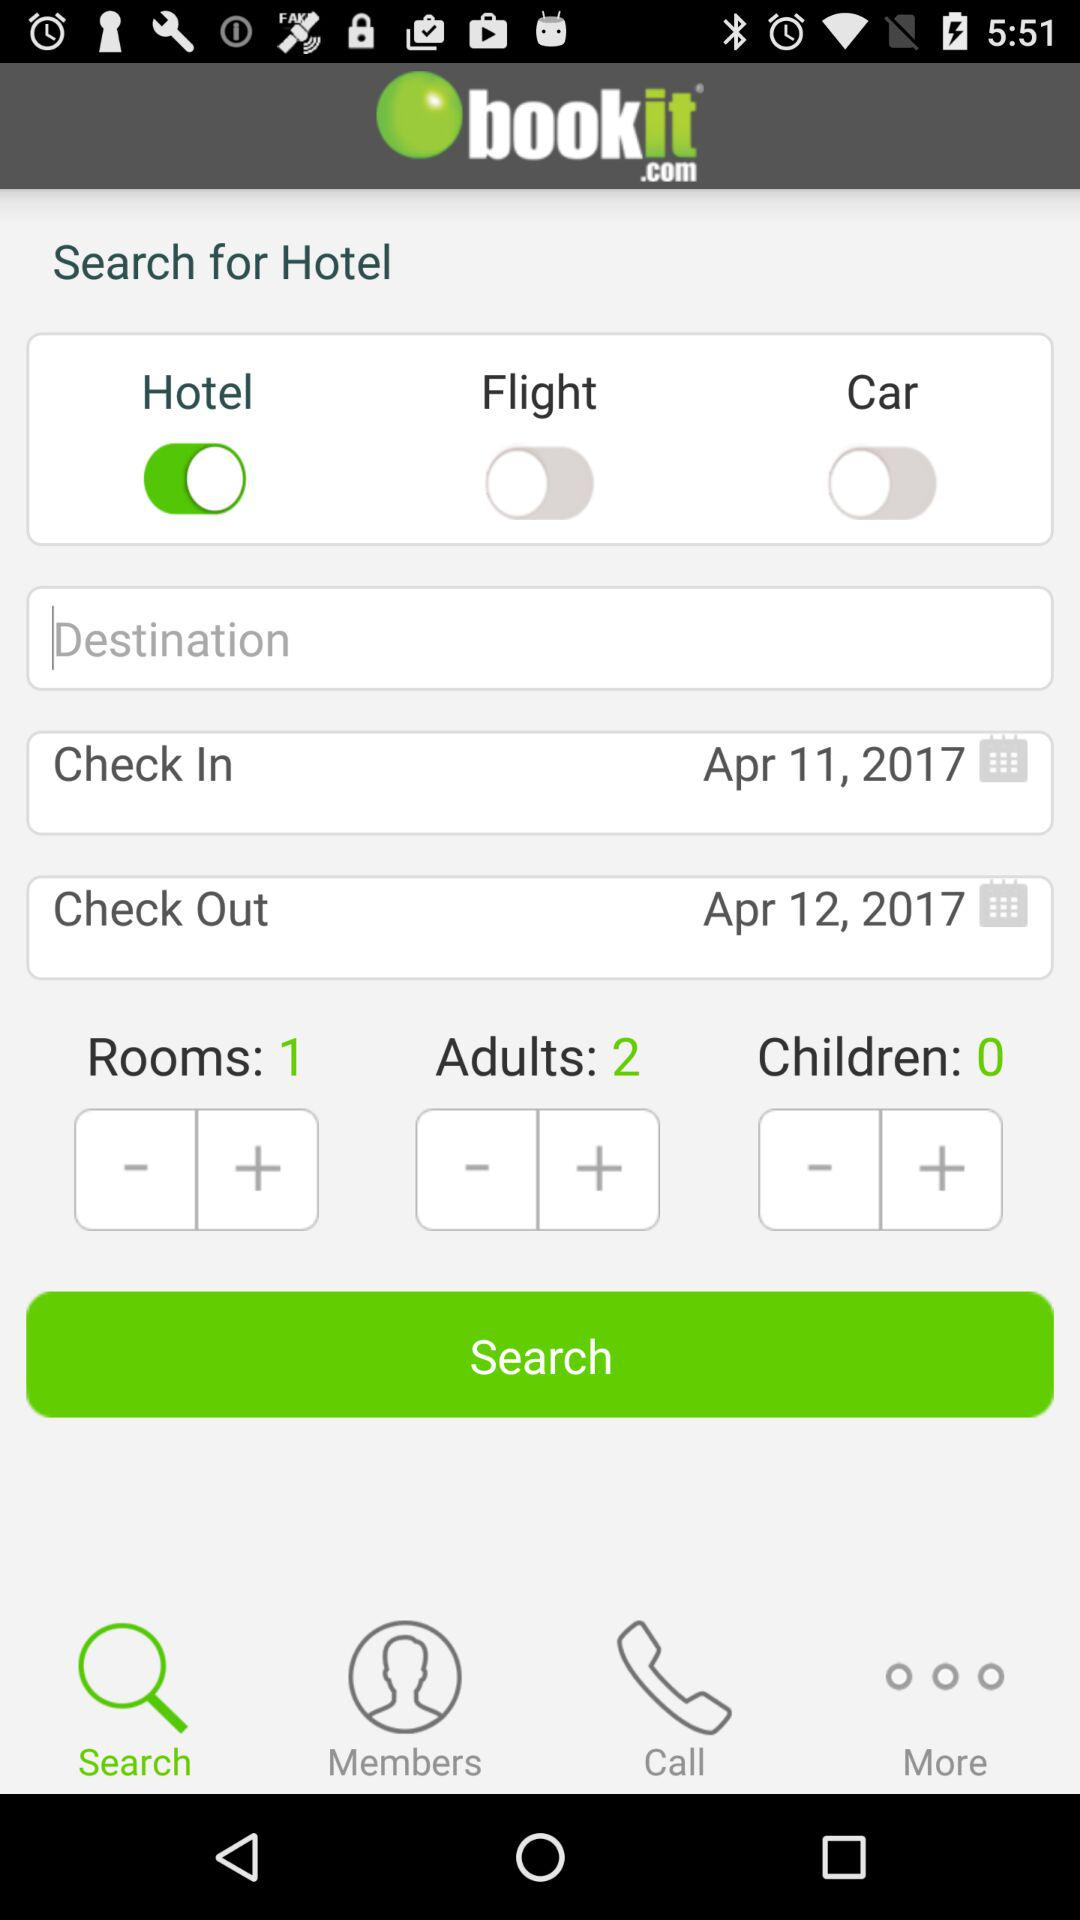Which tab is selected? The selected tab is "Search". 